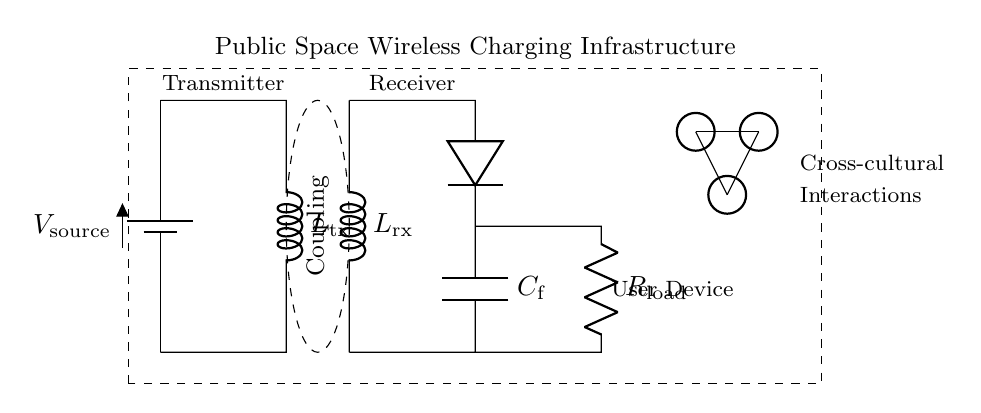What is the role of L in this circuit? The component L represents the inductance in both the transmitter (L_tx) and the receiver (L_rx). Inductors are used in wireless charging to create a magnetic field which facilitates energy transfer between the transmitter and receiver.
Answer: Inductance How many components are in the load section? The load section consists of one resistor, labeled R_load. It represents the component that the electrical energy will be delivered to in the circuit.
Answer: One What is the purpose of the diode in this circuit? The diode is used to allow current to flow in only one direction, ensuring the rectification of the alternating current (AC) generated by the wireless charging receiver into direct current (DC) for the load.
Answer: Rectification What does the dashed ellipse represent? The dashed ellipse signifies the coupling area where magnetic energy is transferred between the transmitter and receiver coils, illustrating the region where cross-coupling occurs.
Answer: Coupling area What is the total voltage provided by the battery? The battery labeled as V_source provides a voltage potential, though the exact value is not given in the diagram. It typically represents a standard voltage.
Answer: Not specified What type of infrastructure does this circuit represent? This circuit illustrates a wireless charging infrastructure that supports public space usage, enabling multiple users to charge devices wirelessly.
Answer: Public space infrastructure 